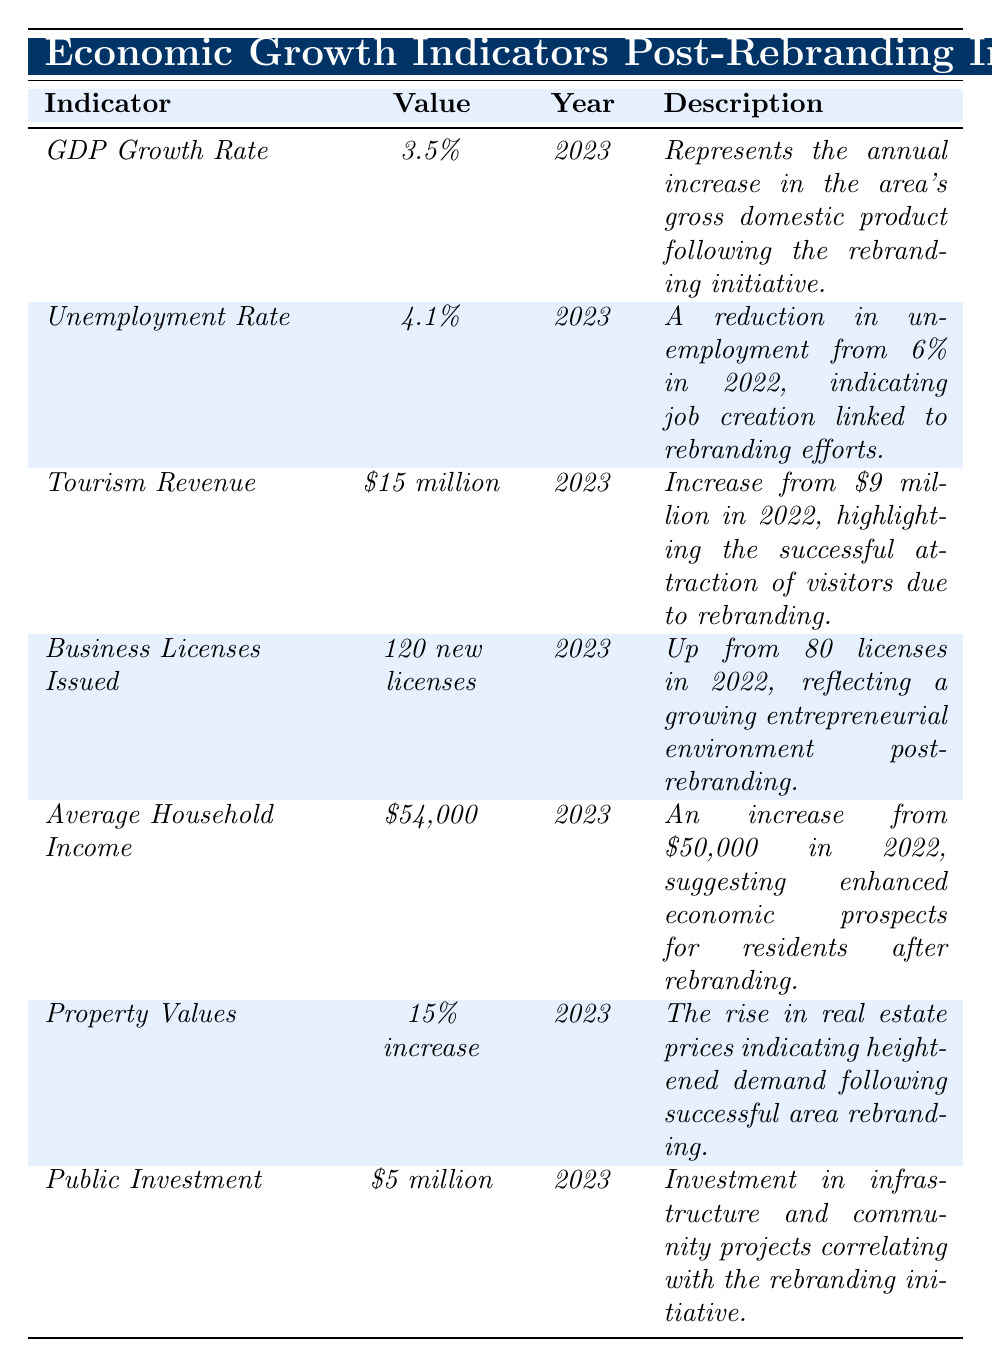What is the GDP growth rate for 2023? The table shows that the GDP Growth Rate for 2023 is listed as 3.5%.
Answer: 3.5% What is the unemployment rate in 2023? According to the table, the unemployment rate in 2023 is 4.1%.
Answer: 4.1% How much did tourism revenue increase from 2022 to 2023? The table shows tourism revenue increased from $9 million in 2022 to $15 million in 2023, which is an increase of $6 million.
Answer: $6 million What is the percentage reduction in unemployment from 2022 to 2023? The unemployment rate decreased from 6% in 2022 to 4.1% in 2023, which is a reduction of 1.9 percentage points.
Answer: 1.9 percentage points How many business licenses were issued in 2023 compared to 2022? The table indicates that 120 business licenses were issued in 2023, up from 80 in 2022, resulting in an increase of 40 licenses.
Answer: 40 licenses What was the average household income in 2022? The table states that the average household income in 2023 is $54,000, and it increased from $50,000 in 2022, so the average household income in 2022 was $50,000.
Answer: $50,000 Is the average household income higher in 2023 compared to 2022? Yes, the average household income in 2023 is $54,000 which is higher than $50,000 in 2022.
Answer: Yes How much public investment was made in 2023? The table indicates that public investment in 2023 is $5 million.
Answer: $5 million What is the overall trend in property values from 2022 to 2023? Property values increased by 15% in 2023, indicating a positive trend as compared to the previous year.
Answer: Positive trend If the tourism revenue continues to increase at the same rate as from 2022 to 2023, what will it be in 2024? The increase in tourism revenue from $9 million in 2022 to $15 million in 2023 was $6 million, indicating a yearly increase of approximately 66.67%. If this increase continues, the revenue in 2024 would be approximately $25 million ($15 million + $10 million).
Answer: Approximately $25 million What does the 15% increase in property values indicate about the area's real estate market? A 15% increase in property values suggests heightened demand for real estate in the area, likely driven by the positive impacts of the rebranding initiative.
Answer: Heightened demand If there were 80 business licenses issued in 2022 and 120 in 2023, what was the percentage increase? The increase in business licenses is 40 (120-80) from 2022 to 2023. The percentage increase is (40/80) * 100 = 50%.
Answer: 50% 